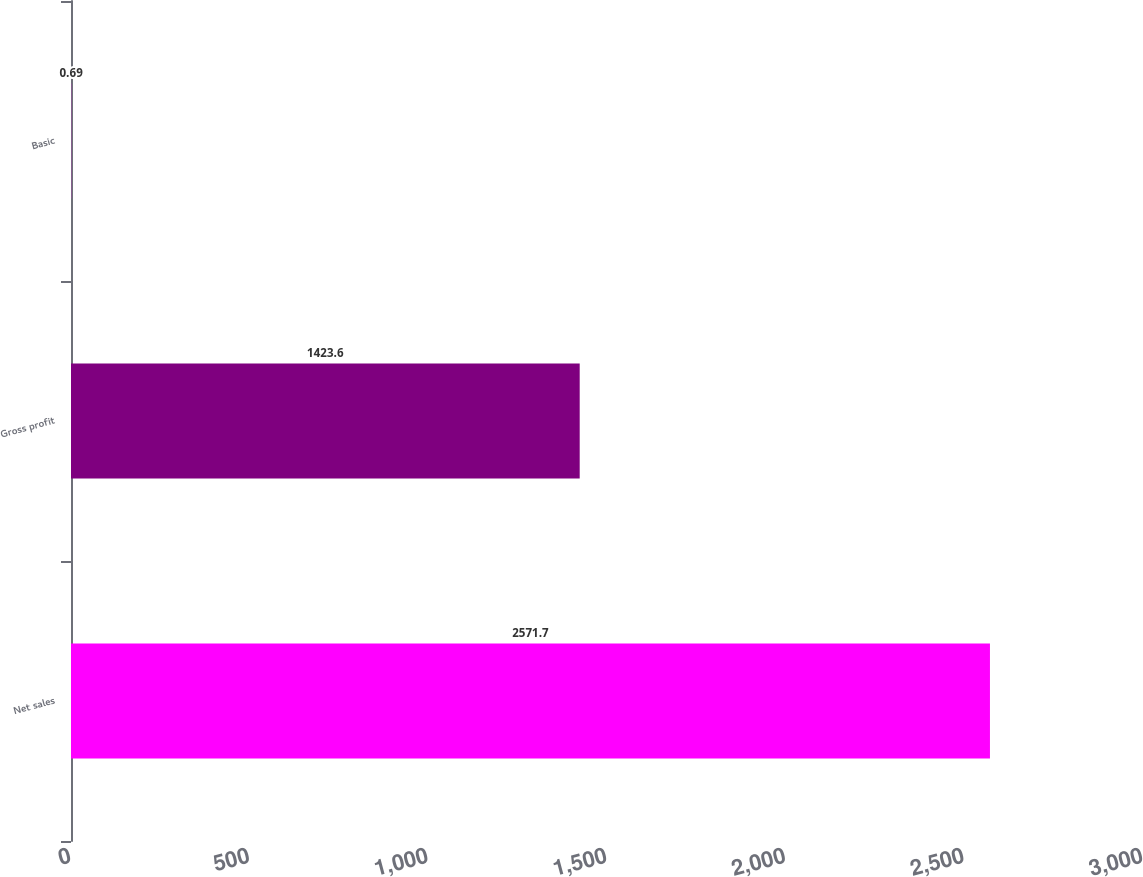Convert chart. <chart><loc_0><loc_0><loc_500><loc_500><bar_chart><fcel>Net sales<fcel>Gross profit<fcel>Basic<nl><fcel>2571.7<fcel>1423.6<fcel>0.69<nl></chart> 